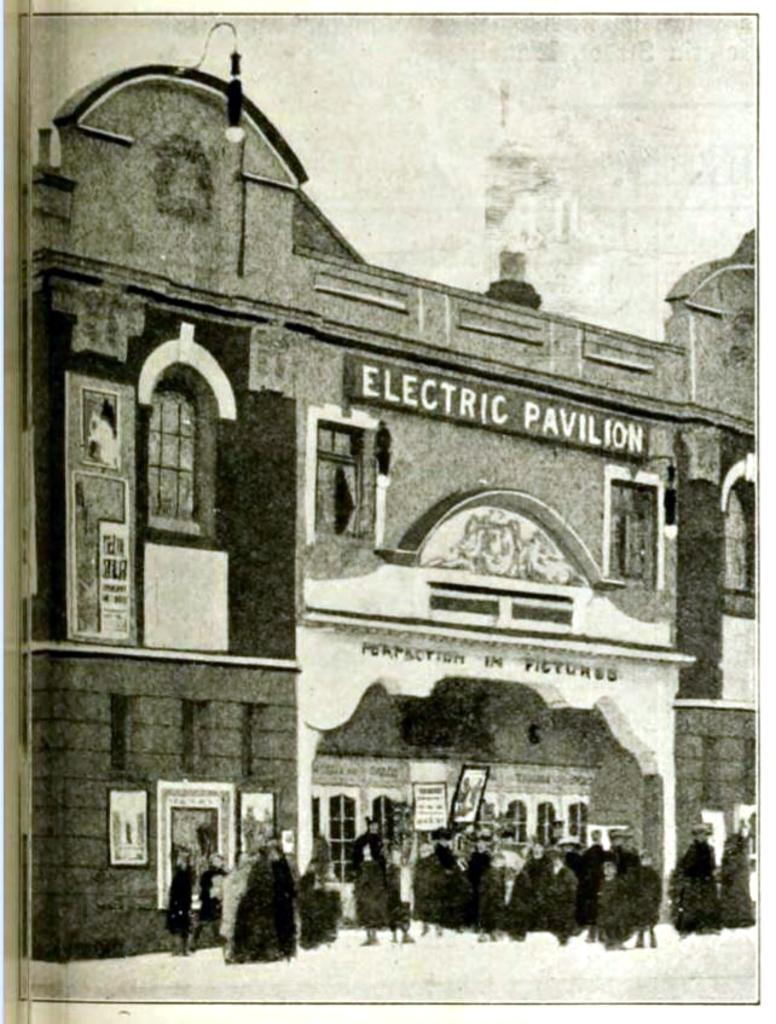What type of artwork is depicted in the image? The image appears to be a painting. What is the main subject of the painting? There is a building in the painting. What is written on the building? The building has the text "ELECTRIC PAVILION" written on it. How many people are in front of the building? There are many people in front of the building. How many eggs are visible on the roof of the building in the painting? There are no eggs visible on the roof of the building in the painting. What type of force is being applied to the building in the painting? There is no indication of any force being applied to the building in the painting. 